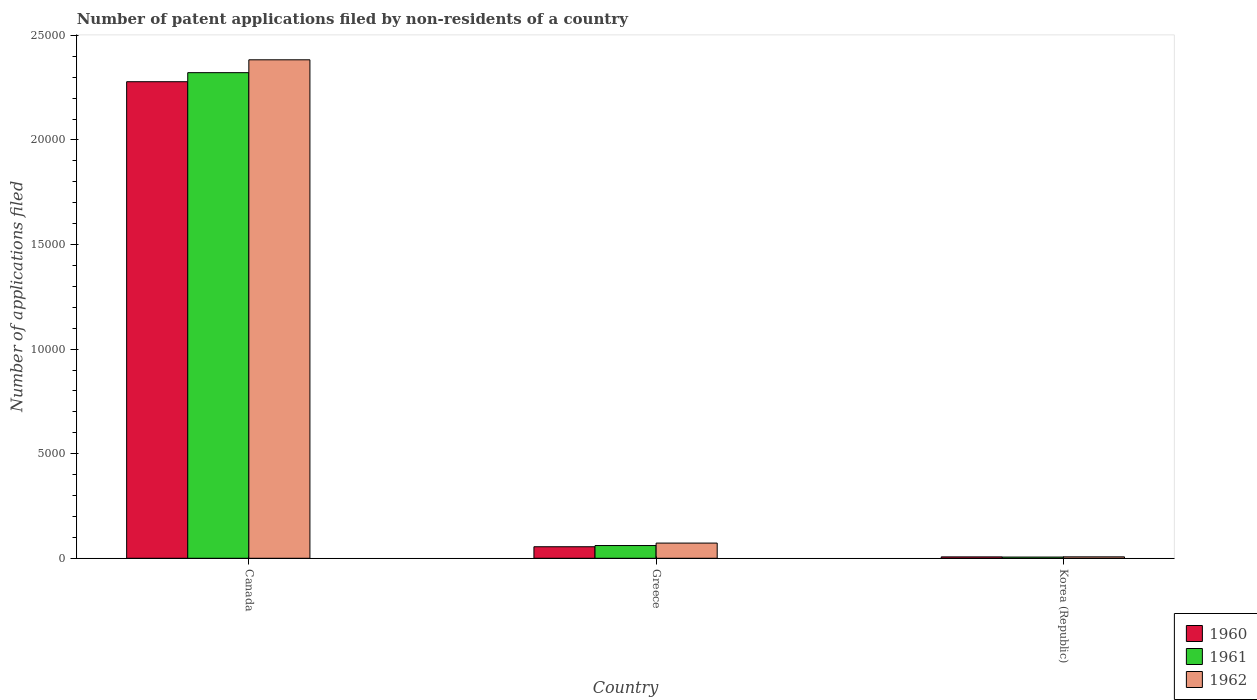Are the number of bars per tick equal to the number of legend labels?
Keep it short and to the point. Yes. Are the number of bars on each tick of the X-axis equal?
Ensure brevity in your answer.  Yes. What is the label of the 2nd group of bars from the left?
Give a very brief answer. Greece. What is the number of applications filed in 1962 in Canada?
Make the answer very short. 2.38e+04. Across all countries, what is the maximum number of applications filed in 1961?
Offer a terse response. 2.32e+04. Across all countries, what is the minimum number of applications filed in 1960?
Your response must be concise. 66. What is the total number of applications filed in 1962 in the graph?
Keep it short and to the point. 2.46e+04. What is the difference between the number of applications filed in 1961 in Canada and that in Greece?
Your answer should be compact. 2.26e+04. What is the difference between the number of applications filed in 1960 in Korea (Republic) and the number of applications filed in 1962 in Canada?
Provide a short and direct response. -2.38e+04. What is the average number of applications filed in 1962 per country?
Offer a terse response. 8209.33. What is the difference between the number of applications filed of/in 1962 and number of applications filed of/in 1960 in Canada?
Offer a very short reply. 1048. In how many countries, is the number of applications filed in 1960 greater than 14000?
Offer a terse response. 1. What is the ratio of the number of applications filed in 1960 in Canada to that in Greece?
Provide a short and direct response. 41.35. Is the number of applications filed in 1961 in Canada less than that in Korea (Republic)?
Keep it short and to the point. No. What is the difference between the highest and the second highest number of applications filed in 1962?
Offer a very short reply. 2.38e+04. What is the difference between the highest and the lowest number of applications filed in 1961?
Make the answer very short. 2.32e+04. Is the sum of the number of applications filed in 1962 in Canada and Greece greater than the maximum number of applications filed in 1961 across all countries?
Your response must be concise. Yes. What does the 3rd bar from the left in Korea (Republic) represents?
Ensure brevity in your answer.  1962. Is it the case that in every country, the sum of the number of applications filed in 1960 and number of applications filed in 1962 is greater than the number of applications filed in 1961?
Make the answer very short. Yes. Does the graph contain grids?
Your answer should be compact. No. Where does the legend appear in the graph?
Offer a terse response. Bottom right. What is the title of the graph?
Give a very brief answer. Number of patent applications filed by non-residents of a country. What is the label or title of the Y-axis?
Your answer should be very brief. Number of applications filed. What is the Number of applications filed of 1960 in Canada?
Make the answer very short. 2.28e+04. What is the Number of applications filed of 1961 in Canada?
Ensure brevity in your answer.  2.32e+04. What is the Number of applications filed in 1962 in Canada?
Offer a terse response. 2.38e+04. What is the Number of applications filed of 1960 in Greece?
Keep it short and to the point. 551. What is the Number of applications filed of 1961 in Greece?
Provide a succinct answer. 609. What is the Number of applications filed of 1962 in Greece?
Your answer should be compact. 726. What is the Number of applications filed in 1960 in Korea (Republic)?
Your answer should be compact. 66. Across all countries, what is the maximum Number of applications filed of 1960?
Your response must be concise. 2.28e+04. Across all countries, what is the maximum Number of applications filed of 1961?
Make the answer very short. 2.32e+04. Across all countries, what is the maximum Number of applications filed of 1962?
Your answer should be very brief. 2.38e+04. What is the total Number of applications filed of 1960 in the graph?
Ensure brevity in your answer.  2.34e+04. What is the total Number of applications filed in 1961 in the graph?
Your answer should be compact. 2.39e+04. What is the total Number of applications filed in 1962 in the graph?
Offer a terse response. 2.46e+04. What is the difference between the Number of applications filed in 1960 in Canada and that in Greece?
Your answer should be very brief. 2.22e+04. What is the difference between the Number of applications filed in 1961 in Canada and that in Greece?
Make the answer very short. 2.26e+04. What is the difference between the Number of applications filed in 1962 in Canada and that in Greece?
Your answer should be very brief. 2.31e+04. What is the difference between the Number of applications filed in 1960 in Canada and that in Korea (Republic)?
Offer a terse response. 2.27e+04. What is the difference between the Number of applications filed in 1961 in Canada and that in Korea (Republic)?
Offer a terse response. 2.32e+04. What is the difference between the Number of applications filed of 1962 in Canada and that in Korea (Republic)?
Your response must be concise. 2.38e+04. What is the difference between the Number of applications filed in 1960 in Greece and that in Korea (Republic)?
Provide a short and direct response. 485. What is the difference between the Number of applications filed of 1961 in Greece and that in Korea (Republic)?
Give a very brief answer. 551. What is the difference between the Number of applications filed in 1962 in Greece and that in Korea (Republic)?
Your answer should be very brief. 658. What is the difference between the Number of applications filed of 1960 in Canada and the Number of applications filed of 1961 in Greece?
Offer a terse response. 2.22e+04. What is the difference between the Number of applications filed of 1960 in Canada and the Number of applications filed of 1962 in Greece?
Provide a succinct answer. 2.21e+04. What is the difference between the Number of applications filed in 1961 in Canada and the Number of applications filed in 1962 in Greece?
Offer a very short reply. 2.25e+04. What is the difference between the Number of applications filed in 1960 in Canada and the Number of applications filed in 1961 in Korea (Republic)?
Offer a very short reply. 2.27e+04. What is the difference between the Number of applications filed of 1960 in Canada and the Number of applications filed of 1962 in Korea (Republic)?
Your response must be concise. 2.27e+04. What is the difference between the Number of applications filed of 1961 in Canada and the Number of applications filed of 1962 in Korea (Republic)?
Provide a short and direct response. 2.32e+04. What is the difference between the Number of applications filed of 1960 in Greece and the Number of applications filed of 1961 in Korea (Republic)?
Provide a succinct answer. 493. What is the difference between the Number of applications filed in 1960 in Greece and the Number of applications filed in 1962 in Korea (Republic)?
Your answer should be compact. 483. What is the difference between the Number of applications filed in 1961 in Greece and the Number of applications filed in 1962 in Korea (Republic)?
Make the answer very short. 541. What is the average Number of applications filed in 1960 per country?
Your answer should be very brief. 7801. What is the average Number of applications filed of 1961 per country?
Ensure brevity in your answer.  7962. What is the average Number of applications filed in 1962 per country?
Your answer should be very brief. 8209.33. What is the difference between the Number of applications filed of 1960 and Number of applications filed of 1961 in Canada?
Offer a terse response. -433. What is the difference between the Number of applications filed of 1960 and Number of applications filed of 1962 in Canada?
Your response must be concise. -1048. What is the difference between the Number of applications filed in 1961 and Number of applications filed in 1962 in Canada?
Give a very brief answer. -615. What is the difference between the Number of applications filed of 1960 and Number of applications filed of 1961 in Greece?
Your response must be concise. -58. What is the difference between the Number of applications filed of 1960 and Number of applications filed of 1962 in Greece?
Offer a terse response. -175. What is the difference between the Number of applications filed of 1961 and Number of applications filed of 1962 in Greece?
Your answer should be very brief. -117. What is the difference between the Number of applications filed of 1960 and Number of applications filed of 1961 in Korea (Republic)?
Ensure brevity in your answer.  8. What is the ratio of the Number of applications filed in 1960 in Canada to that in Greece?
Offer a terse response. 41.35. What is the ratio of the Number of applications filed of 1961 in Canada to that in Greece?
Your answer should be very brief. 38.13. What is the ratio of the Number of applications filed of 1962 in Canada to that in Greece?
Offer a terse response. 32.83. What is the ratio of the Number of applications filed of 1960 in Canada to that in Korea (Republic)?
Ensure brevity in your answer.  345.24. What is the ratio of the Number of applications filed in 1961 in Canada to that in Korea (Republic)?
Keep it short and to the point. 400.33. What is the ratio of the Number of applications filed in 1962 in Canada to that in Korea (Republic)?
Your answer should be compact. 350.5. What is the ratio of the Number of applications filed of 1960 in Greece to that in Korea (Republic)?
Offer a very short reply. 8.35. What is the ratio of the Number of applications filed of 1961 in Greece to that in Korea (Republic)?
Ensure brevity in your answer.  10.5. What is the ratio of the Number of applications filed in 1962 in Greece to that in Korea (Republic)?
Offer a terse response. 10.68. What is the difference between the highest and the second highest Number of applications filed in 1960?
Your answer should be very brief. 2.22e+04. What is the difference between the highest and the second highest Number of applications filed of 1961?
Give a very brief answer. 2.26e+04. What is the difference between the highest and the second highest Number of applications filed of 1962?
Make the answer very short. 2.31e+04. What is the difference between the highest and the lowest Number of applications filed in 1960?
Provide a succinct answer. 2.27e+04. What is the difference between the highest and the lowest Number of applications filed of 1961?
Your response must be concise. 2.32e+04. What is the difference between the highest and the lowest Number of applications filed in 1962?
Keep it short and to the point. 2.38e+04. 